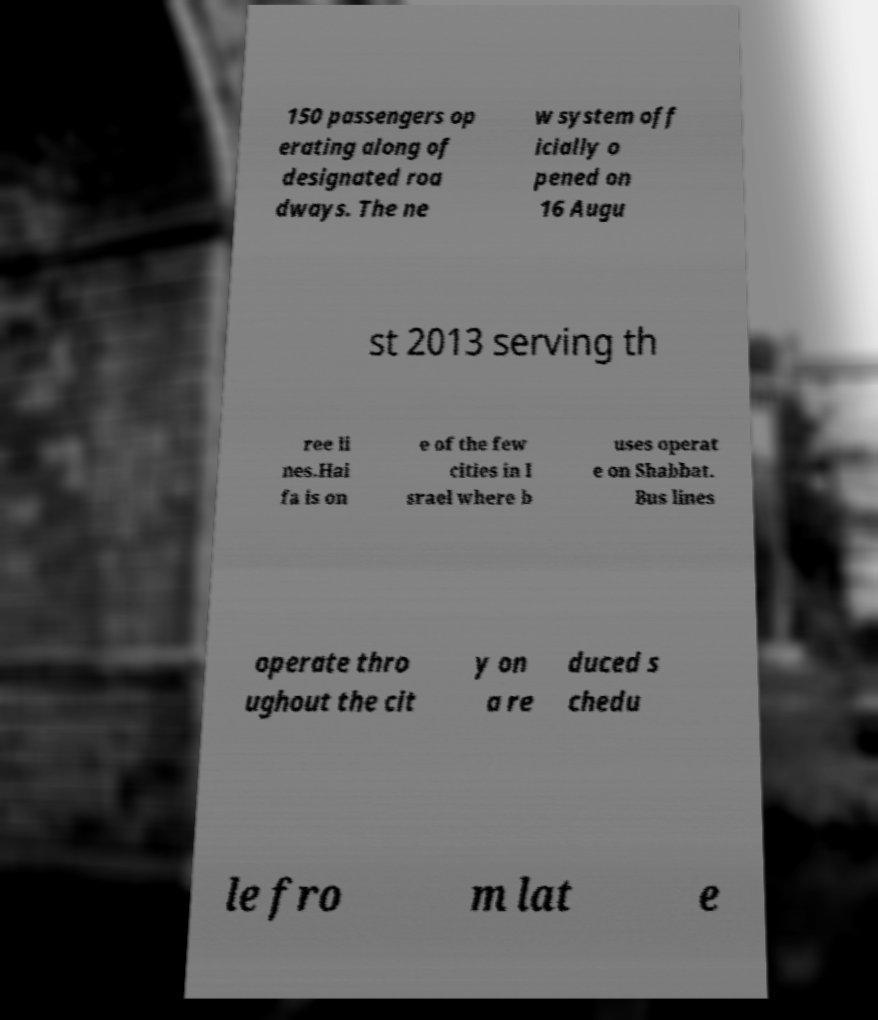What messages or text are displayed in this image? I need them in a readable, typed format. 150 passengers op erating along of designated roa dways. The ne w system off icially o pened on 16 Augu st 2013 serving th ree li nes.Hai fa is on e of the few cities in I srael where b uses operat e on Shabbat. Bus lines operate thro ughout the cit y on a re duced s chedu le fro m lat e 